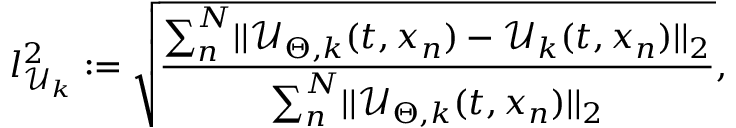Convert formula to latex. <formula><loc_0><loc_0><loc_500><loc_500>l _ { \mathcal { U } _ { k } } ^ { 2 } \colon = \sqrt { \frac { \sum _ { n } ^ { N } \mathopen | \mathopen | \mathcal { U } _ { \Theta , k } ( t , x _ { n } ) - \mathcal { U } _ { k } ( t , x _ { n } ) \mathclose | \mathclose | _ { 2 } } { \sum _ { n } ^ { N } \mathopen | \mathopen | \mathcal { U } _ { \Theta , k } ( t , x _ { n } ) \mathclose | \mathclose | _ { 2 } } } ,</formula> 